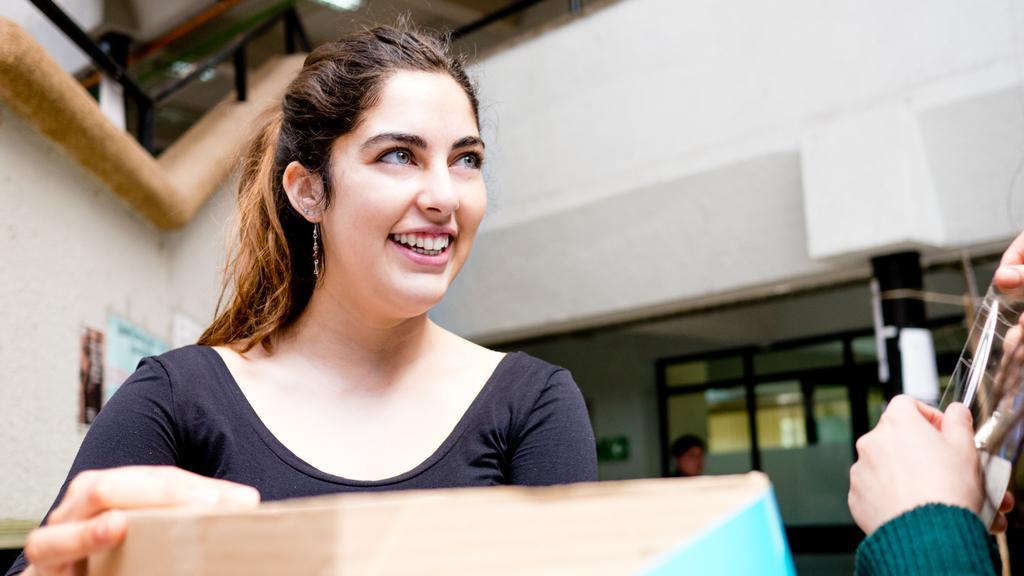Can you describe this image briefly? In this image there is a girl in the middle who is laughing by holding the box. On the right side there is a person who is holding the plaster. In the background there is a building. On the left side top there is a staircase. 